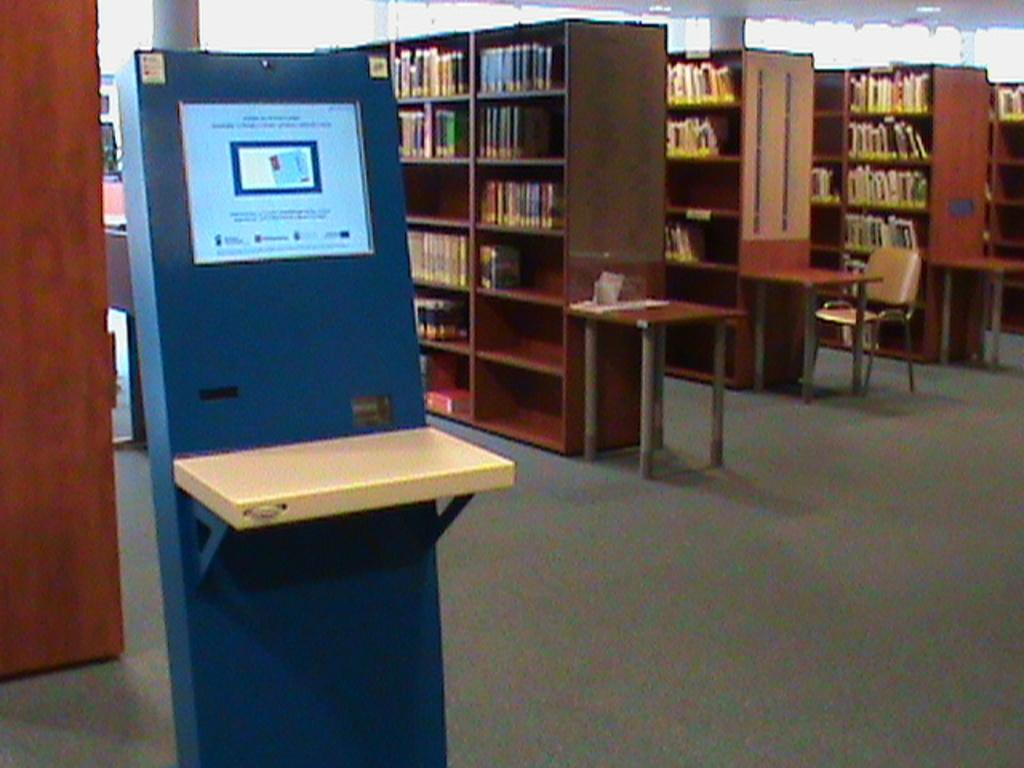What type of place is depicted in the image? The image is of a library. What can be found in the library? There are books in a rack in the library. What device is located on the left side of the image? There is a digital machine on the left side of the image. Can you hear the spoon crying in the image? There is no spoon or any crying sound in the image, as it depicts a library with books and a digital machine. 